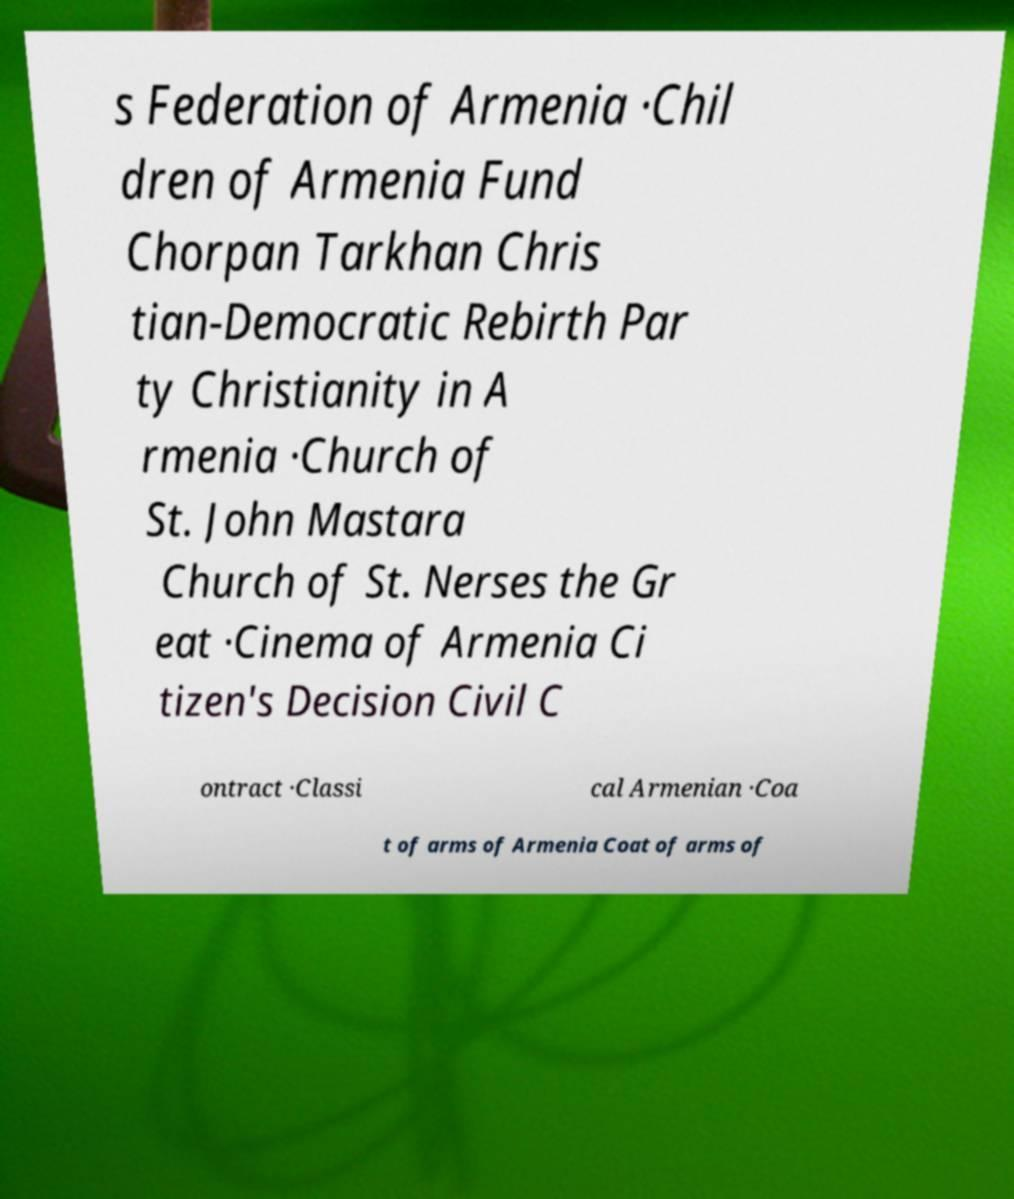Could you extract and type out the text from this image? s Federation of Armenia ·Chil dren of Armenia Fund Chorpan Tarkhan Chris tian-Democratic Rebirth Par ty Christianity in A rmenia ·Church of St. John Mastara Church of St. Nerses the Gr eat ·Cinema of Armenia Ci tizen's Decision Civil C ontract ·Classi cal Armenian ·Coa t of arms of Armenia Coat of arms of 